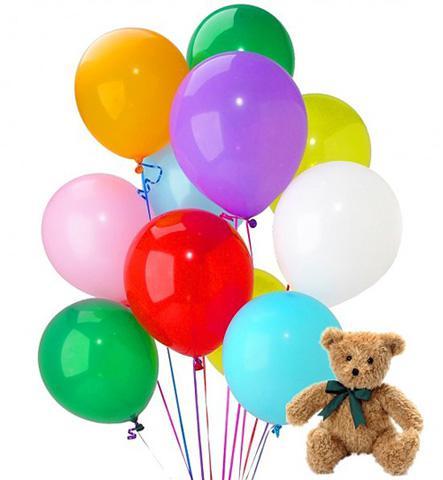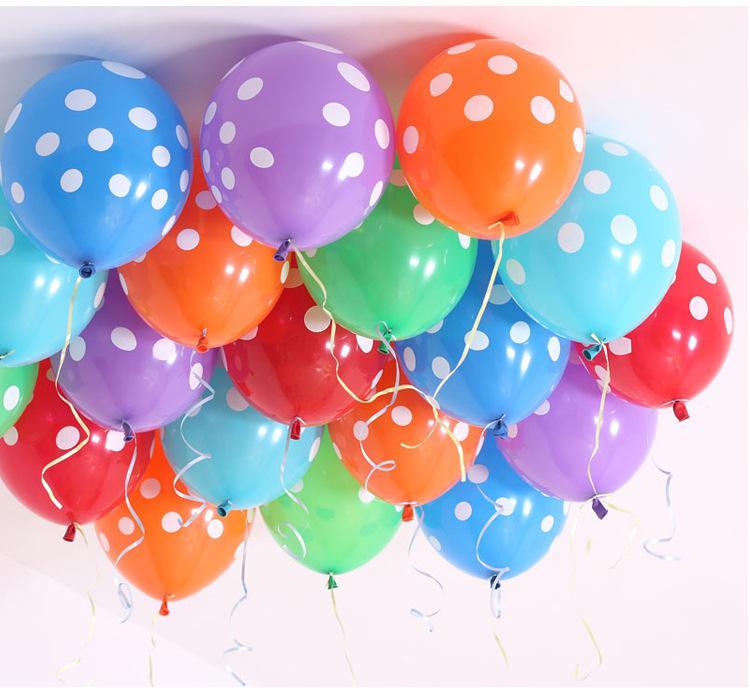The first image is the image on the left, the second image is the image on the right. For the images shown, is this caption "In one of the images there is a stuffed bear next to multiple solid colored balloons." true? Answer yes or no. Yes. 